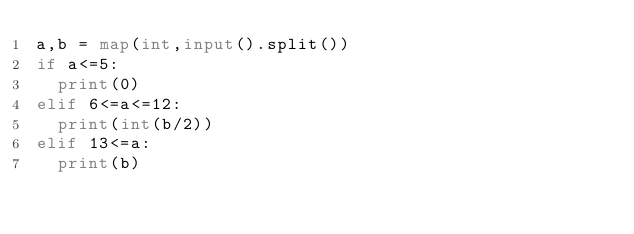Convert code to text. <code><loc_0><loc_0><loc_500><loc_500><_Python_>a,b = map(int,input().split())
if a<=5:
  print(0)
elif 6<=a<=12:
  print(int(b/2))
elif 13<=a:
  print(b)</code> 